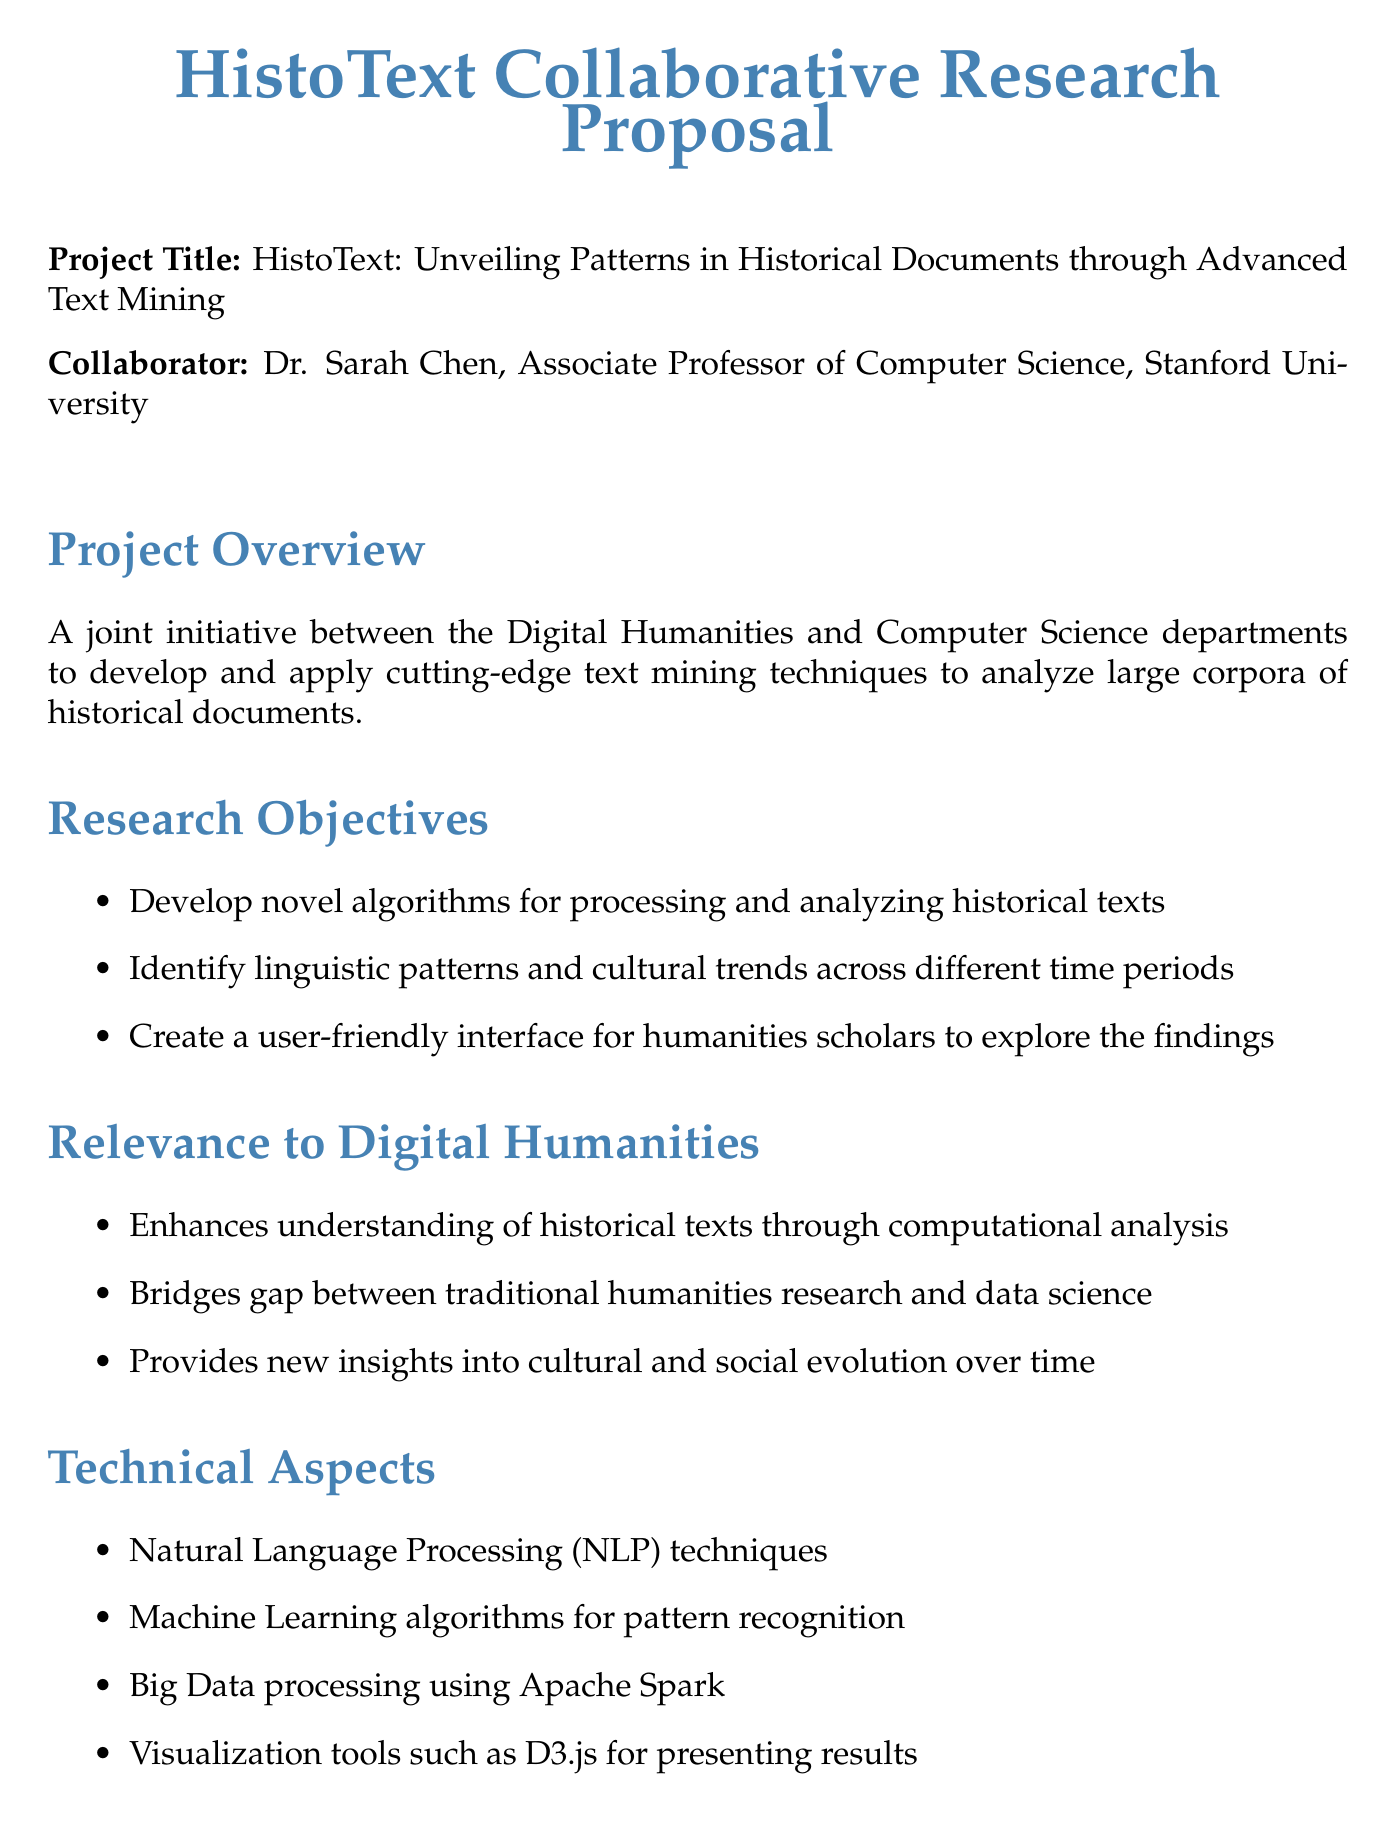What is the project title? The project title is stated at the beginning of the document, specifying the focus of the research proposal.
Answer: HistoText: Unveiling Patterns in Historical Documents through Advanced Text Mining Who is the primary collaborator? The document lists Dr. Sarah Chen as the collaborator and provides her title and institution.
Answer: Dr. Sarah Chen What is the name of the dataset used in the project? The dataset's name is mentioned in the dataset section, detailing its source and contents.
Answer: The British Library's Digitized Manuscripts Collection How long is the project expected to last? The duration of the project is specified in the timeline section, indicating the total length of the research initiative.
Answer: 2 years What is one expected outcome of the project? The expected outcomes are listed, highlighting specific achievements anticipated from the research.
Answer: Publication of research findings in top-tier journals What funding sources are mentioned? The document outlines the funding sources available for the project, which supports its financial backing.
Answer: National Endowment for the Humanities, National Science Foundation What is a potential challenge mentioned in the document? The document identifies challenges to be faced during the research, indicating difficulties that may arise.
Answer: Dealing with inconsistencies in historical spelling and grammar How does the project impact the curriculum? The document describes ways in which the project findings will affect educational programs in related fields.
Answer: Integration of project findings into Digital Humanities courses What type of tools will be developed according to expected outcomes? The expected outcomes section specifies the type of tools expected to come from this initiative, emphasizing their purpose.
Answer: Open-source tools for historical text analysis 